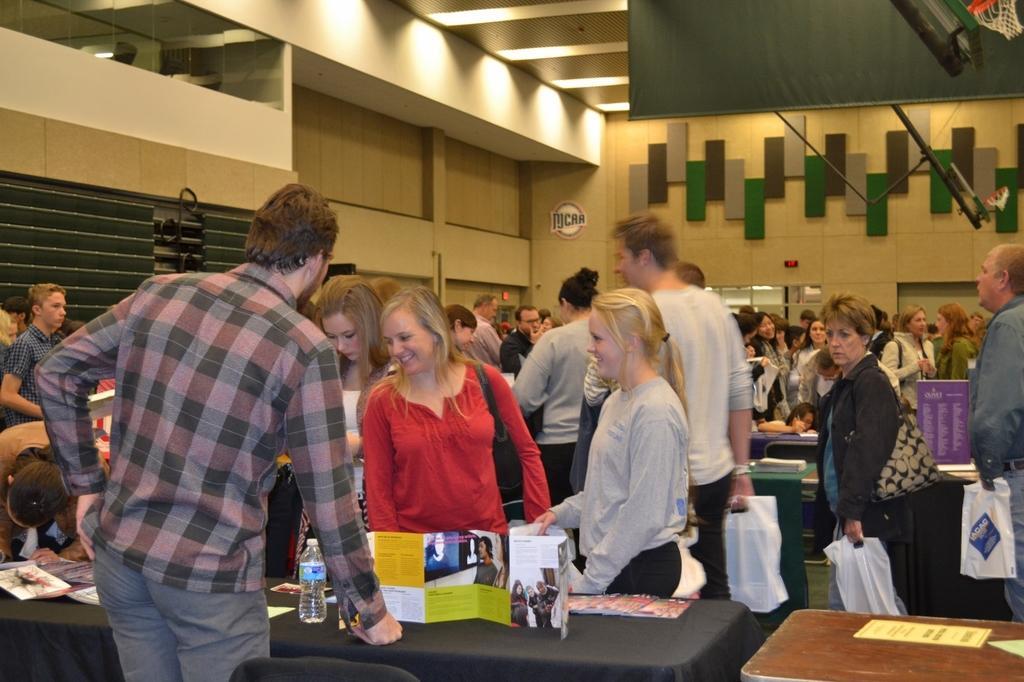Could you give a brief overview of what you see in this image? In this image there are group of people standing near the table and in table there are paper, book , bottle and in back ground there are lights , screen , basketball net and group of people standing. 